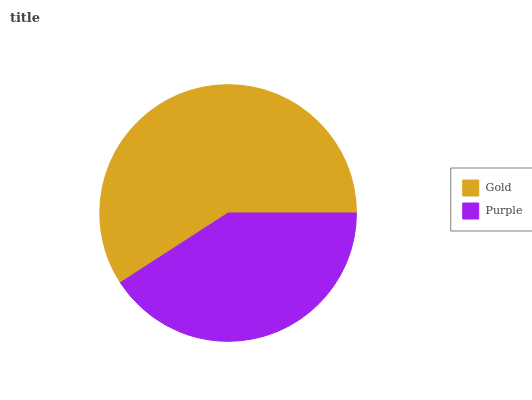Is Purple the minimum?
Answer yes or no. Yes. Is Gold the maximum?
Answer yes or no. Yes. Is Purple the maximum?
Answer yes or no. No. Is Gold greater than Purple?
Answer yes or no. Yes. Is Purple less than Gold?
Answer yes or no. Yes. Is Purple greater than Gold?
Answer yes or no. No. Is Gold less than Purple?
Answer yes or no. No. Is Gold the high median?
Answer yes or no. Yes. Is Purple the low median?
Answer yes or no. Yes. Is Purple the high median?
Answer yes or no. No. Is Gold the low median?
Answer yes or no. No. 